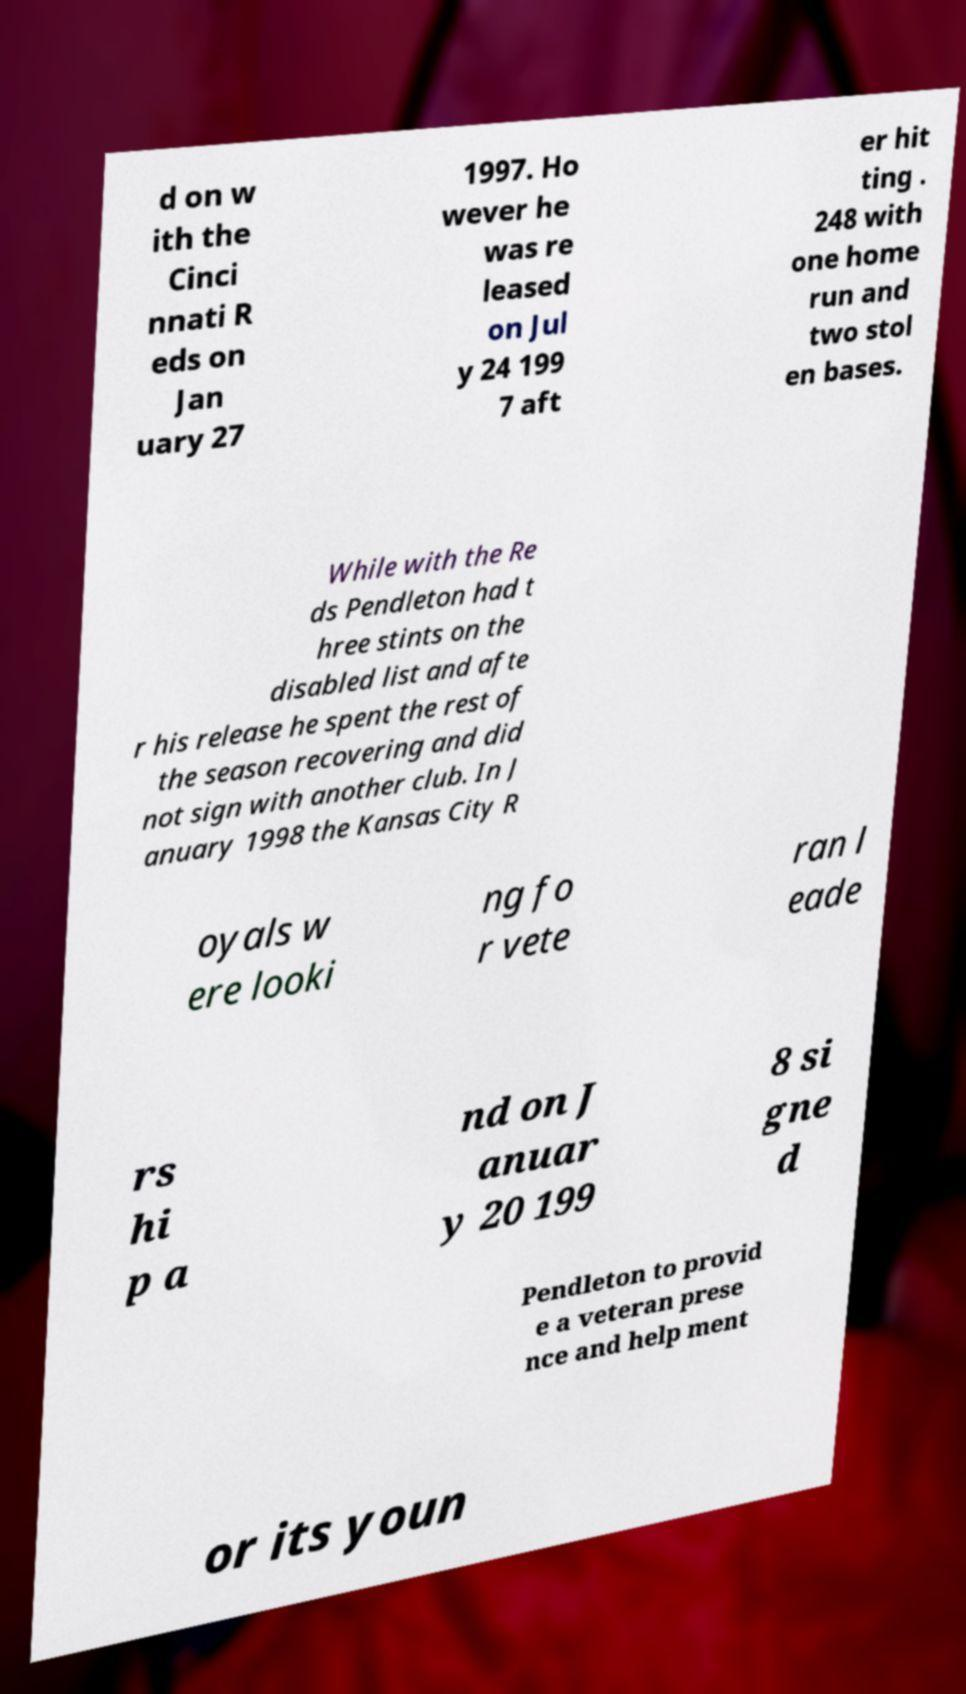What messages or text are displayed in this image? I need them in a readable, typed format. d on w ith the Cinci nnati R eds on Jan uary 27 1997. Ho wever he was re leased on Jul y 24 199 7 aft er hit ting . 248 with one home run and two stol en bases. While with the Re ds Pendleton had t hree stints on the disabled list and afte r his release he spent the rest of the season recovering and did not sign with another club. In J anuary 1998 the Kansas City R oyals w ere looki ng fo r vete ran l eade rs hi p a nd on J anuar y 20 199 8 si gne d Pendleton to provid e a veteran prese nce and help ment or its youn 